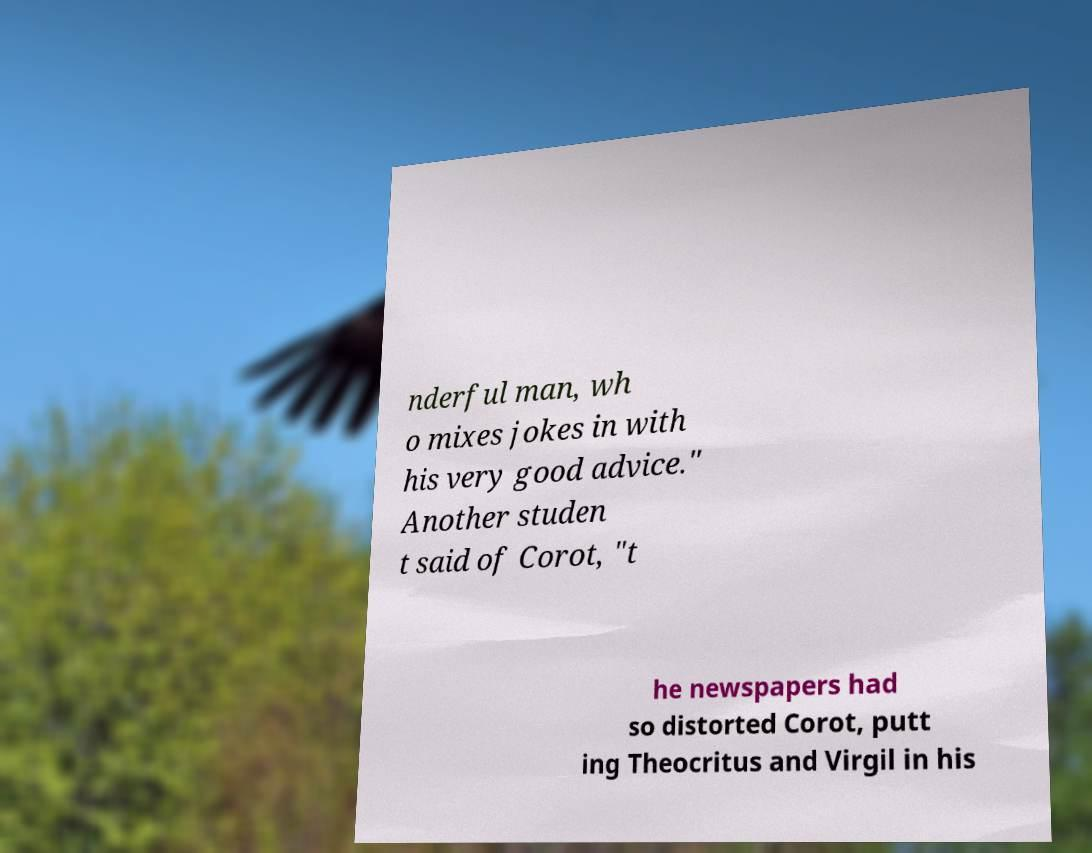Please identify and transcribe the text found in this image. nderful man, wh o mixes jokes in with his very good advice." Another studen t said of Corot, "t he newspapers had so distorted Corot, putt ing Theocritus and Virgil in his 